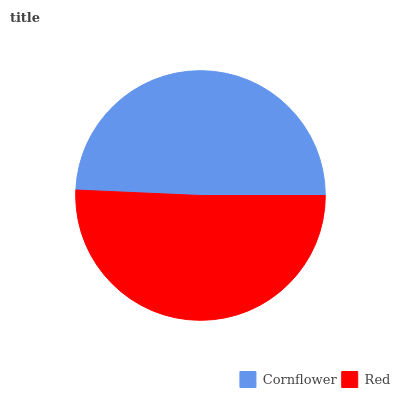Is Cornflower the minimum?
Answer yes or no. Yes. Is Red the maximum?
Answer yes or no. Yes. Is Red the minimum?
Answer yes or no. No. Is Red greater than Cornflower?
Answer yes or no. Yes. Is Cornflower less than Red?
Answer yes or no. Yes. Is Cornflower greater than Red?
Answer yes or no. No. Is Red less than Cornflower?
Answer yes or no. No. Is Red the high median?
Answer yes or no. Yes. Is Cornflower the low median?
Answer yes or no. Yes. Is Cornflower the high median?
Answer yes or no. No. Is Red the low median?
Answer yes or no. No. 